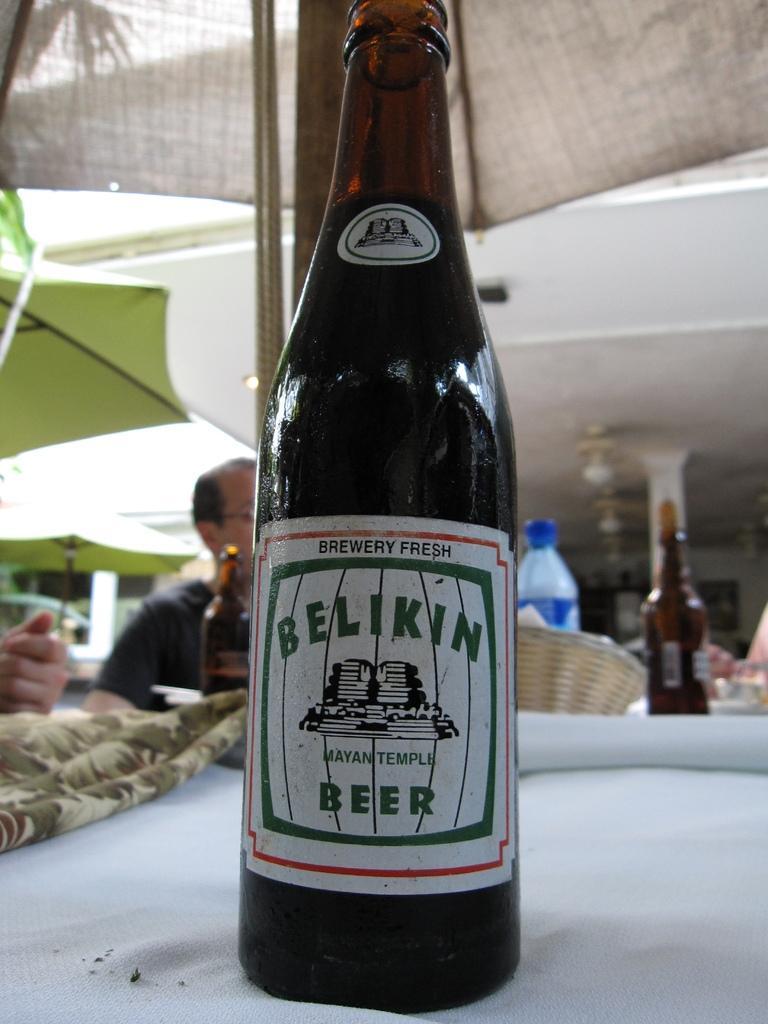Describe this image in one or two sentences. Here we can see a wine bottle on the table and in front here is the person sitting and some objects here, and at above here is the roof. 